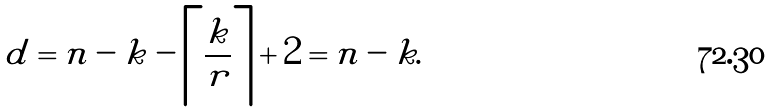<formula> <loc_0><loc_0><loc_500><loc_500>d = n - k - \left \lceil \frac { k } { r } \right \rceil + 2 = n - k .</formula> 